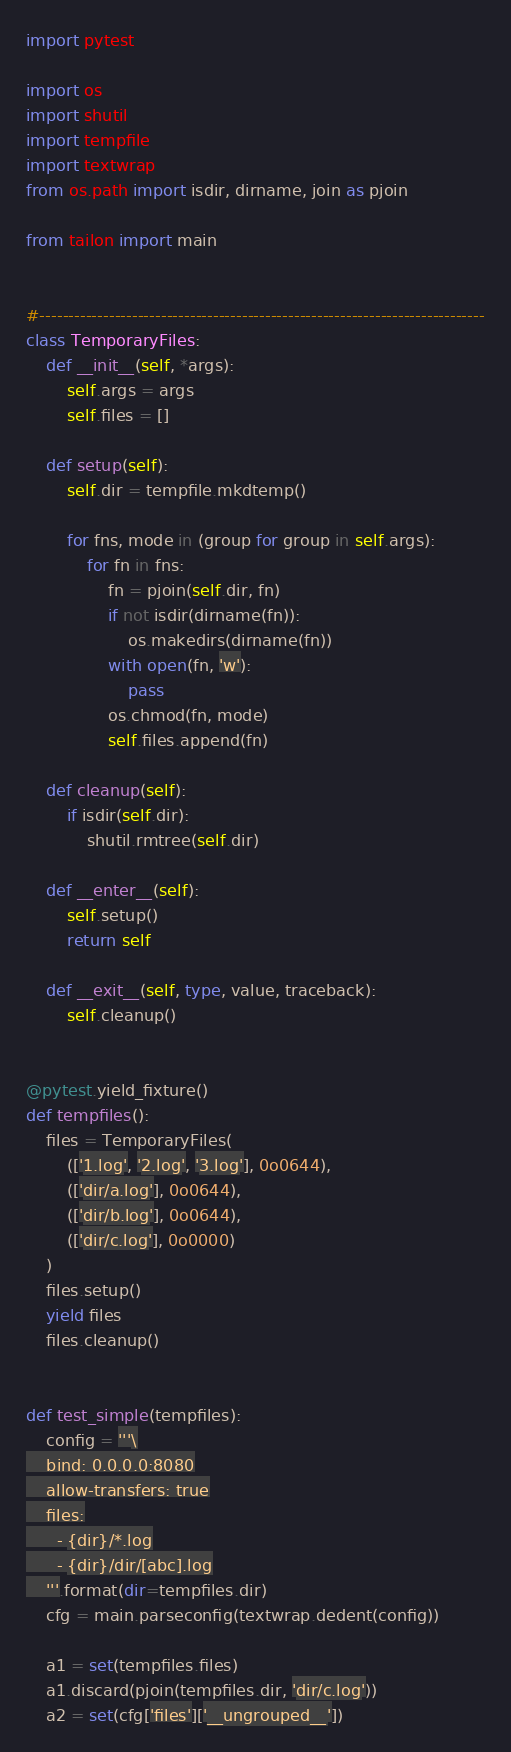<code> <loc_0><loc_0><loc_500><loc_500><_Python_>import pytest

import os
import shutil
import tempfile
import textwrap
from os.path import isdir, dirname, join as pjoin

from tailon import main


#-----------------------------------------------------------------------------
class TemporaryFiles:
    def __init__(self, *args):
        self.args = args
        self.files = []

    def setup(self):
        self.dir = tempfile.mkdtemp()

        for fns, mode in (group for group in self.args):
            for fn in fns:
                fn = pjoin(self.dir, fn)
                if not isdir(dirname(fn)):
                    os.makedirs(dirname(fn))
                with open(fn, 'w'):
                    pass
                os.chmod(fn, mode)
                self.files.append(fn)

    def cleanup(self):
        if isdir(self.dir):
            shutil.rmtree(self.dir)

    def __enter__(self):
        self.setup()
        return self

    def __exit__(self, type, value, traceback):
        self.cleanup()


@pytest.yield_fixture()
def tempfiles():
    files = TemporaryFiles(
        (['1.log', '2.log', '3.log'], 0o0644),
        (['dir/a.log'], 0o0644),
        (['dir/b.log'], 0o0644),
        (['dir/c.log'], 0o0000)
    )
    files.setup()
    yield files
    files.cleanup()


def test_simple(tempfiles):
    config = '''\
    bind: 0.0.0.0:8080
    allow-transfers: true
    files:
      - {dir}/*.log
      - {dir}/dir/[abc].log
    '''.format(dir=tempfiles.dir)
    cfg = main.parseconfig(textwrap.dedent(config))

    a1 = set(tempfiles.files)
    a1.discard(pjoin(tempfiles.dir, 'dir/c.log'))
    a2 = set(cfg['files']['__ungrouped__'])
</code> 